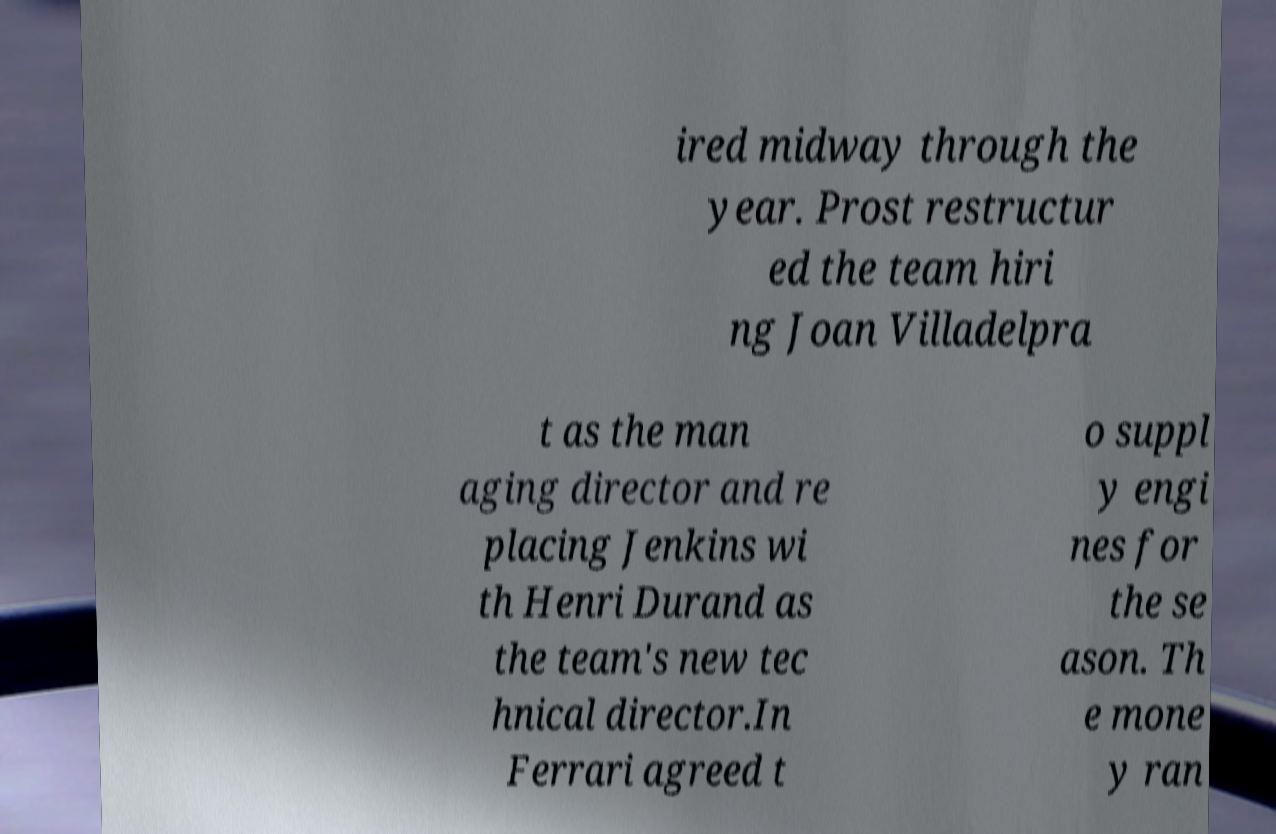I need the written content from this picture converted into text. Can you do that? ired midway through the year. Prost restructur ed the team hiri ng Joan Villadelpra t as the man aging director and re placing Jenkins wi th Henri Durand as the team's new tec hnical director.In Ferrari agreed t o suppl y engi nes for the se ason. Th e mone y ran 